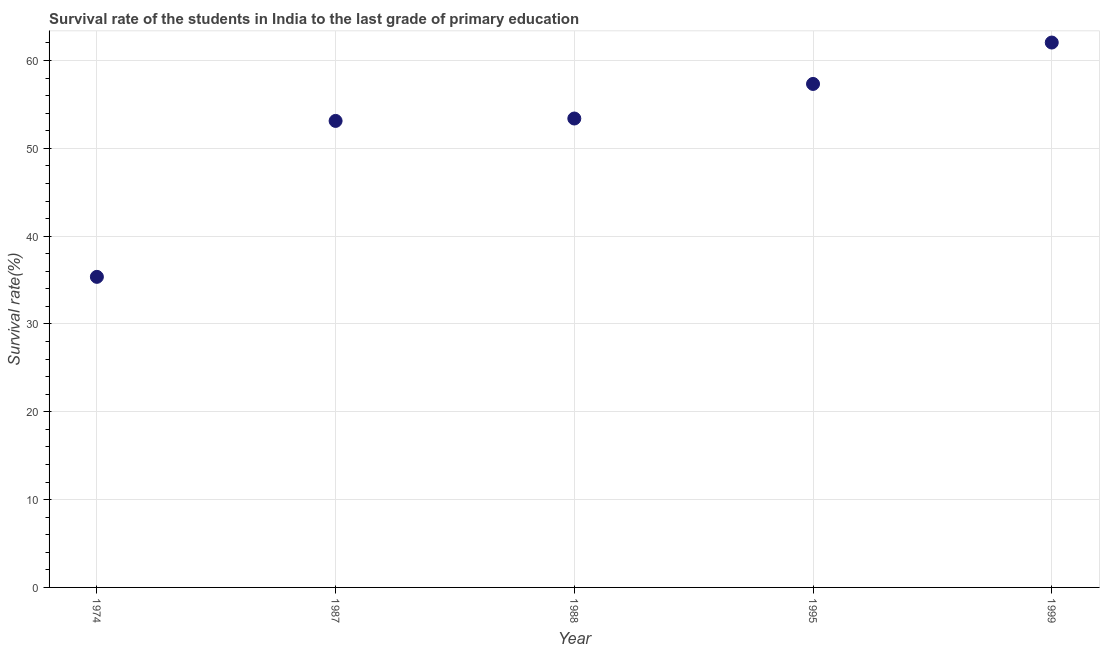What is the survival rate in primary education in 1988?
Offer a terse response. 53.4. Across all years, what is the maximum survival rate in primary education?
Offer a terse response. 62.05. Across all years, what is the minimum survival rate in primary education?
Keep it short and to the point. 35.37. In which year was the survival rate in primary education minimum?
Your response must be concise. 1974. What is the sum of the survival rate in primary education?
Make the answer very short. 261.26. What is the difference between the survival rate in primary education in 1987 and 1988?
Give a very brief answer. -0.27. What is the average survival rate in primary education per year?
Provide a succinct answer. 52.25. What is the median survival rate in primary education?
Offer a terse response. 53.4. What is the ratio of the survival rate in primary education in 1987 to that in 1999?
Give a very brief answer. 0.86. What is the difference between the highest and the second highest survival rate in primary education?
Offer a terse response. 4.71. What is the difference between the highest and the lowest survival rate in primary education?
Keep it short and to the point. 26.68. Does the survival rate in primary education monotonically increase over the years?
Your response must be concise. Yes. How many dotlines are there?
Offer a very short reply. 1. How many years are there in the graph?
Offer a very short reply. 5. What is the difference between two consecutive major ticks on the Y-axis?
Make the answer very short. 10. What is the title of the graph?
Make the answer very short. Survival rate of the students in India to the last grade of primary education. What is the label or title of the Y-axis?
Ensure brevity in your answer.  Survival rate(%). What is the Survival rate(%) in 1974?
Keep it short and to the point. 35.37. What is the Survival rate(%) in 1987?
Provide a short and direct response. 53.12. What is the Survival rate(%) in 1988?
Ensure brevity in your answer.  53.4. What is the Survival rate(%) in 1995?
Keep it short and to the point. 57.33. What is the Survival rate(%) in 1999?
Keep it short and to the point. 62.05. What is the difference between the Survival rate(%) in 1974 and 1987?
Your answer should be very brief. -17.76. What is the difference between the Survival rate(%) in 1974 and 1988?
Your response must be concise. -18.03. What is the difference between the Survival rate(%) in 1974 and 1995?
Give a very brief answer. -21.97. What is the difference between the Survival rate(%) in 1974 and 1999?
Give a very brief answer. -26.68. What is the difference between the Survival rate(%) in 1987 and 1988?
Provide a short and direct response. -0.27. What is the difference between the Survival rate(%) in 1987 and 1995?
Provide a short and direct response. -4.21. What is the difference between the Survival rate(%) in 1987 and 1999?
Make the answer very short. -8.92. What is the difference between the Survival rate(%) in 1988 and 1995?
Provide a succinct answer. -3.94. What is the difference between the Survival rate(%) in 1988 and 1999?
Offer a very short reply. -8.65. What is the difference between the Survival rate(%) in 1995 and 1999?
Your response must be concise. -4.71. What is the ratio of the Survival rate(%) in 1974 to that in 1987?
Offer a terse response. 0.67. What is the ratio of the Survival rate(%) in 1974 to that in 1988?
Give a very brief answer. 0.66. What is the ratio of the Survival rate(%) in 1974 to that in 1995?
Keep it short and to the point. 0.62. What is the ratio of the Survival rate(%) in 1974 to that in 1999?
Your answer should be very brief. 0.57. What is the ratio of the Survival rate(%) in 1987 to that in 1988?
Keep it short and to the point. 0.99. What is the ratio of the Survival rate(%) in 1987 to that in 1995?
Offer a very short reply. 0.93. What is the ratio of the Survival rate(%) in 1987 to that in 1999?
Provide a short and direct response. 0.86. What is the ratio of the Survival rate(%) in 1988 to that in 1995?
Provide a succinct answer. 0.93. What is the ratio of the Survival rate(%) in 1988 to that in 1999?
Your answer should be compact. 0.86. What is the ratio of the Survival rate(%) in 1995 to that in 1999?
Your answer should be compact. 0.92. 